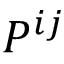Convert formula to latex. <formula><loc_0><loc_0><loc_500><loc_500>P ^ { i j }</formula> 